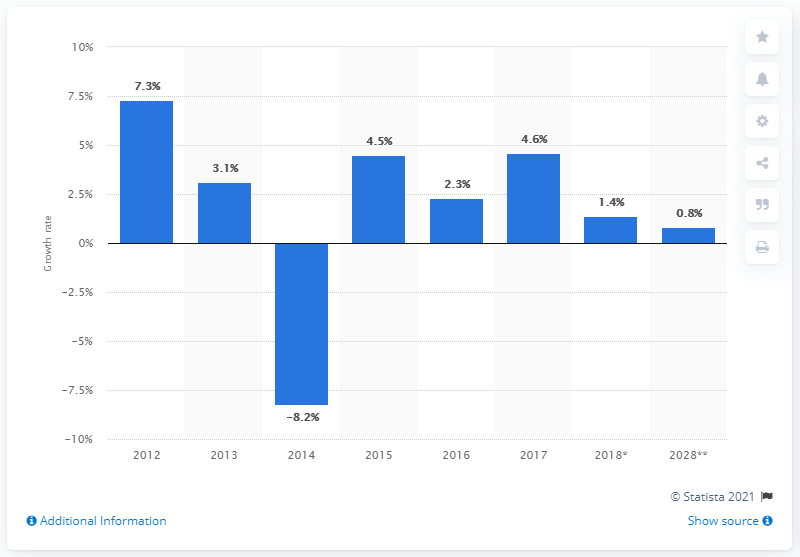Draw attention to some important aspects in this diagram. According to data from 2017, the travel and tourism industry experienced a growth rate of 4.6%. 